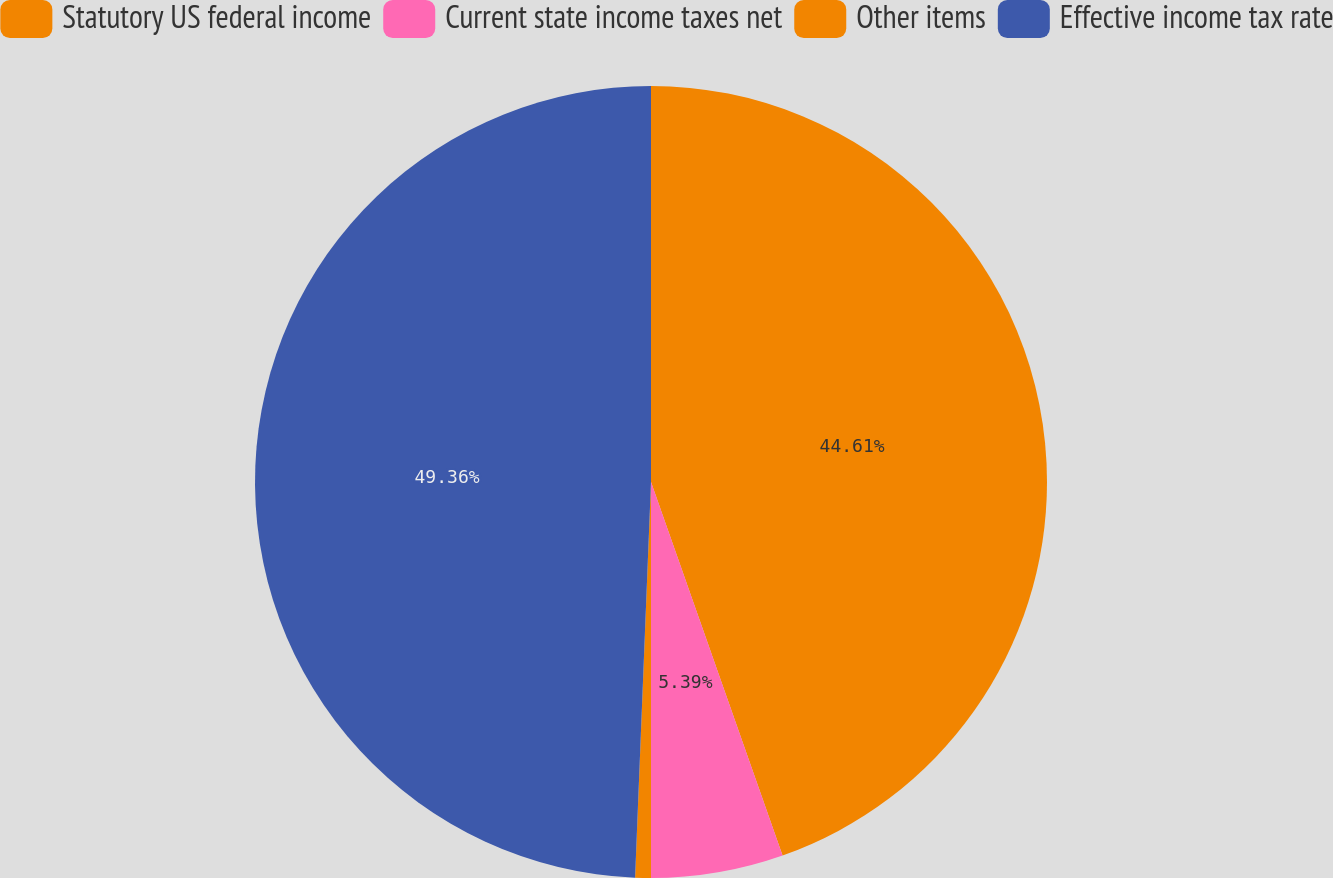<chart> <loc_0><loc_0><loc_500><loc_500><pie_chart><fcel>Statutory US federal income<fcel>Current state income taxes net<fcel>Other items<fcel>Effective income tax rate<nl><fcel>44.61%<fcel>5.39%<fcel>0.64%<fcel>49.36%<nl></chart> 